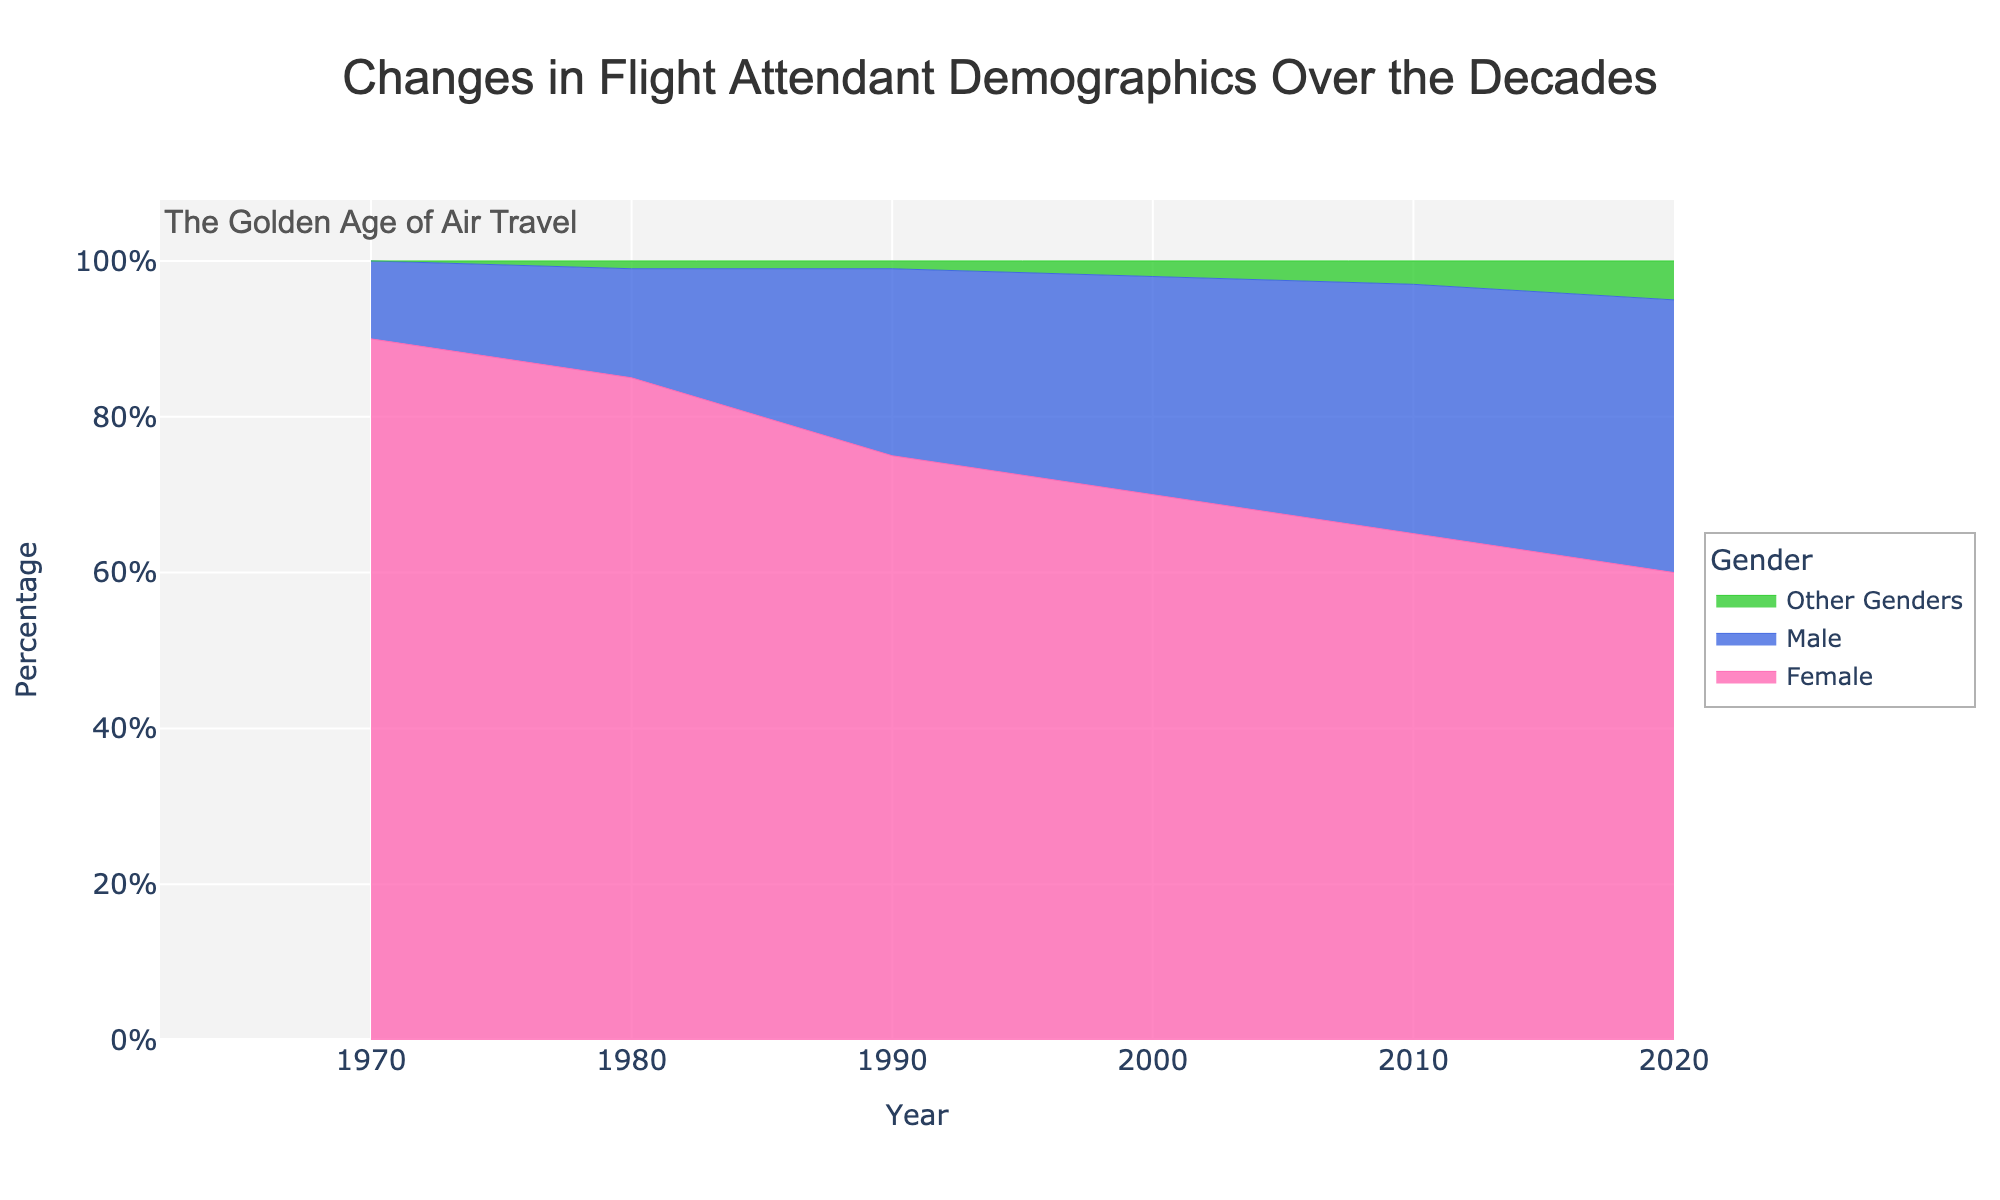What is the title of the figure? The title of the figure is located at the top center of the figure. It reads "Changes in Flight Attendant Demographics Over the Decades".
Answer: Changes in Flight Attendant Demographics Over the Decades What percentage of flight attendants were female in 1990? To find this, look at the year 1990 on the x-axis and check the corresponding value in the area representing females.
Answer: 75% Between which decades did the percentage of male flight attendants increase the most? Compare the increase in the percentage of male flight attendants between each pair of decades. Between 1980 and 1990, the percentage increased from 14% to 24%, a 10% increase, which is the greatest.
Answer: 1980 to 1990 What are the percentages of other genders in the most recent decade shown? Look at the year 2020 on the x-axis and identify the value in the area representing other genders.
Answer: 5% During which decade did the percentage of female flight attendants fall below 70%? Check the stacked areas for each decade; in the year 2000, the percentage of female flight attendants is 70%. The subsequent decade (2010) is when the percentage falls below 70%.
Answer: 2010 What is the sum of the percentages for male and other genders in the year 2020? Sum the values for male and other genders in 2020: 35% (male) + 5% (other genders) = 40%.
Answer: 40% Which gender had the smallest percentage change between 1970 and 2020? Calculate the percentage change for each gender from 1970 to 2020: Female (90% to 60%, 30% decrease), Male (10% to 35%, 25% increase), Other Genders (0% to 5%, 5% increase). The smallest change is for Other Genders (5%).
Answer: Other Genders How has the composition of male flight attendants changed from the 1970s to the 2020s? Examine the stacked area for male flight attendants in 1970 (10%) and 2020 (35%). It shows an increase from 10% to 35%.
Answer: Increased What is the overall trend for female flight attendants from 1970 to 2020? Observe the stacked area for females starting from 1970 to 2020. The percentage decreases from 90% in 1970 to 60% in 2020, showing a downward trend.
Answer: Decreasing Identify the decade with the most significant appearance of other genders. Look for where the area representing other genders begins to noticeably increase. We see the first significant appearance in the 2010s with 3%, followed by further increase to 5% in 2020.
Answer: 2010 